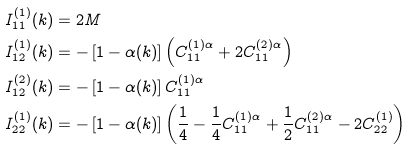<formula> <loc_0><loc_0><loc_500><loc_500>I _ { 1 1 } ^ { ( 1 ) } ( k ) & = 2 M \\ I _ { 1 2 } ^ { ( 1 ) } ( k ) & = - \left [ 1 - \alpha ( k ) \right ] \left ( C _ { 1 1 } ^ { ( 1 ) \alpha } + 2 C _ { 1 1 } ^ { ( 2 ) \alpha } \right ) \\ I _ { 1 2 } ^ { ( 2 ) } ( k ) & = - \left [ 1 - \alpha ( k ) \right ] C _ { 1 1 } ^ { ( 1 ) \alpha } \\ I _ { 2 2 } ^ { ( 1 ) } ( k ) & = - \left [ 1 - \alpha ( k ) \right ] \left ( { \frac { 1 } { 4 } } - { \frac { 1 } { 4 } } C _ { 1 1 } ^ { ( 1 ) \alpha } + { \frac { 1 } { 2 } } C _ { 1 1 } ^ { ( 2 ) \alpha } - 2 C _ { 2 2 } ^ { ( 1 ) } \right )</formula> 